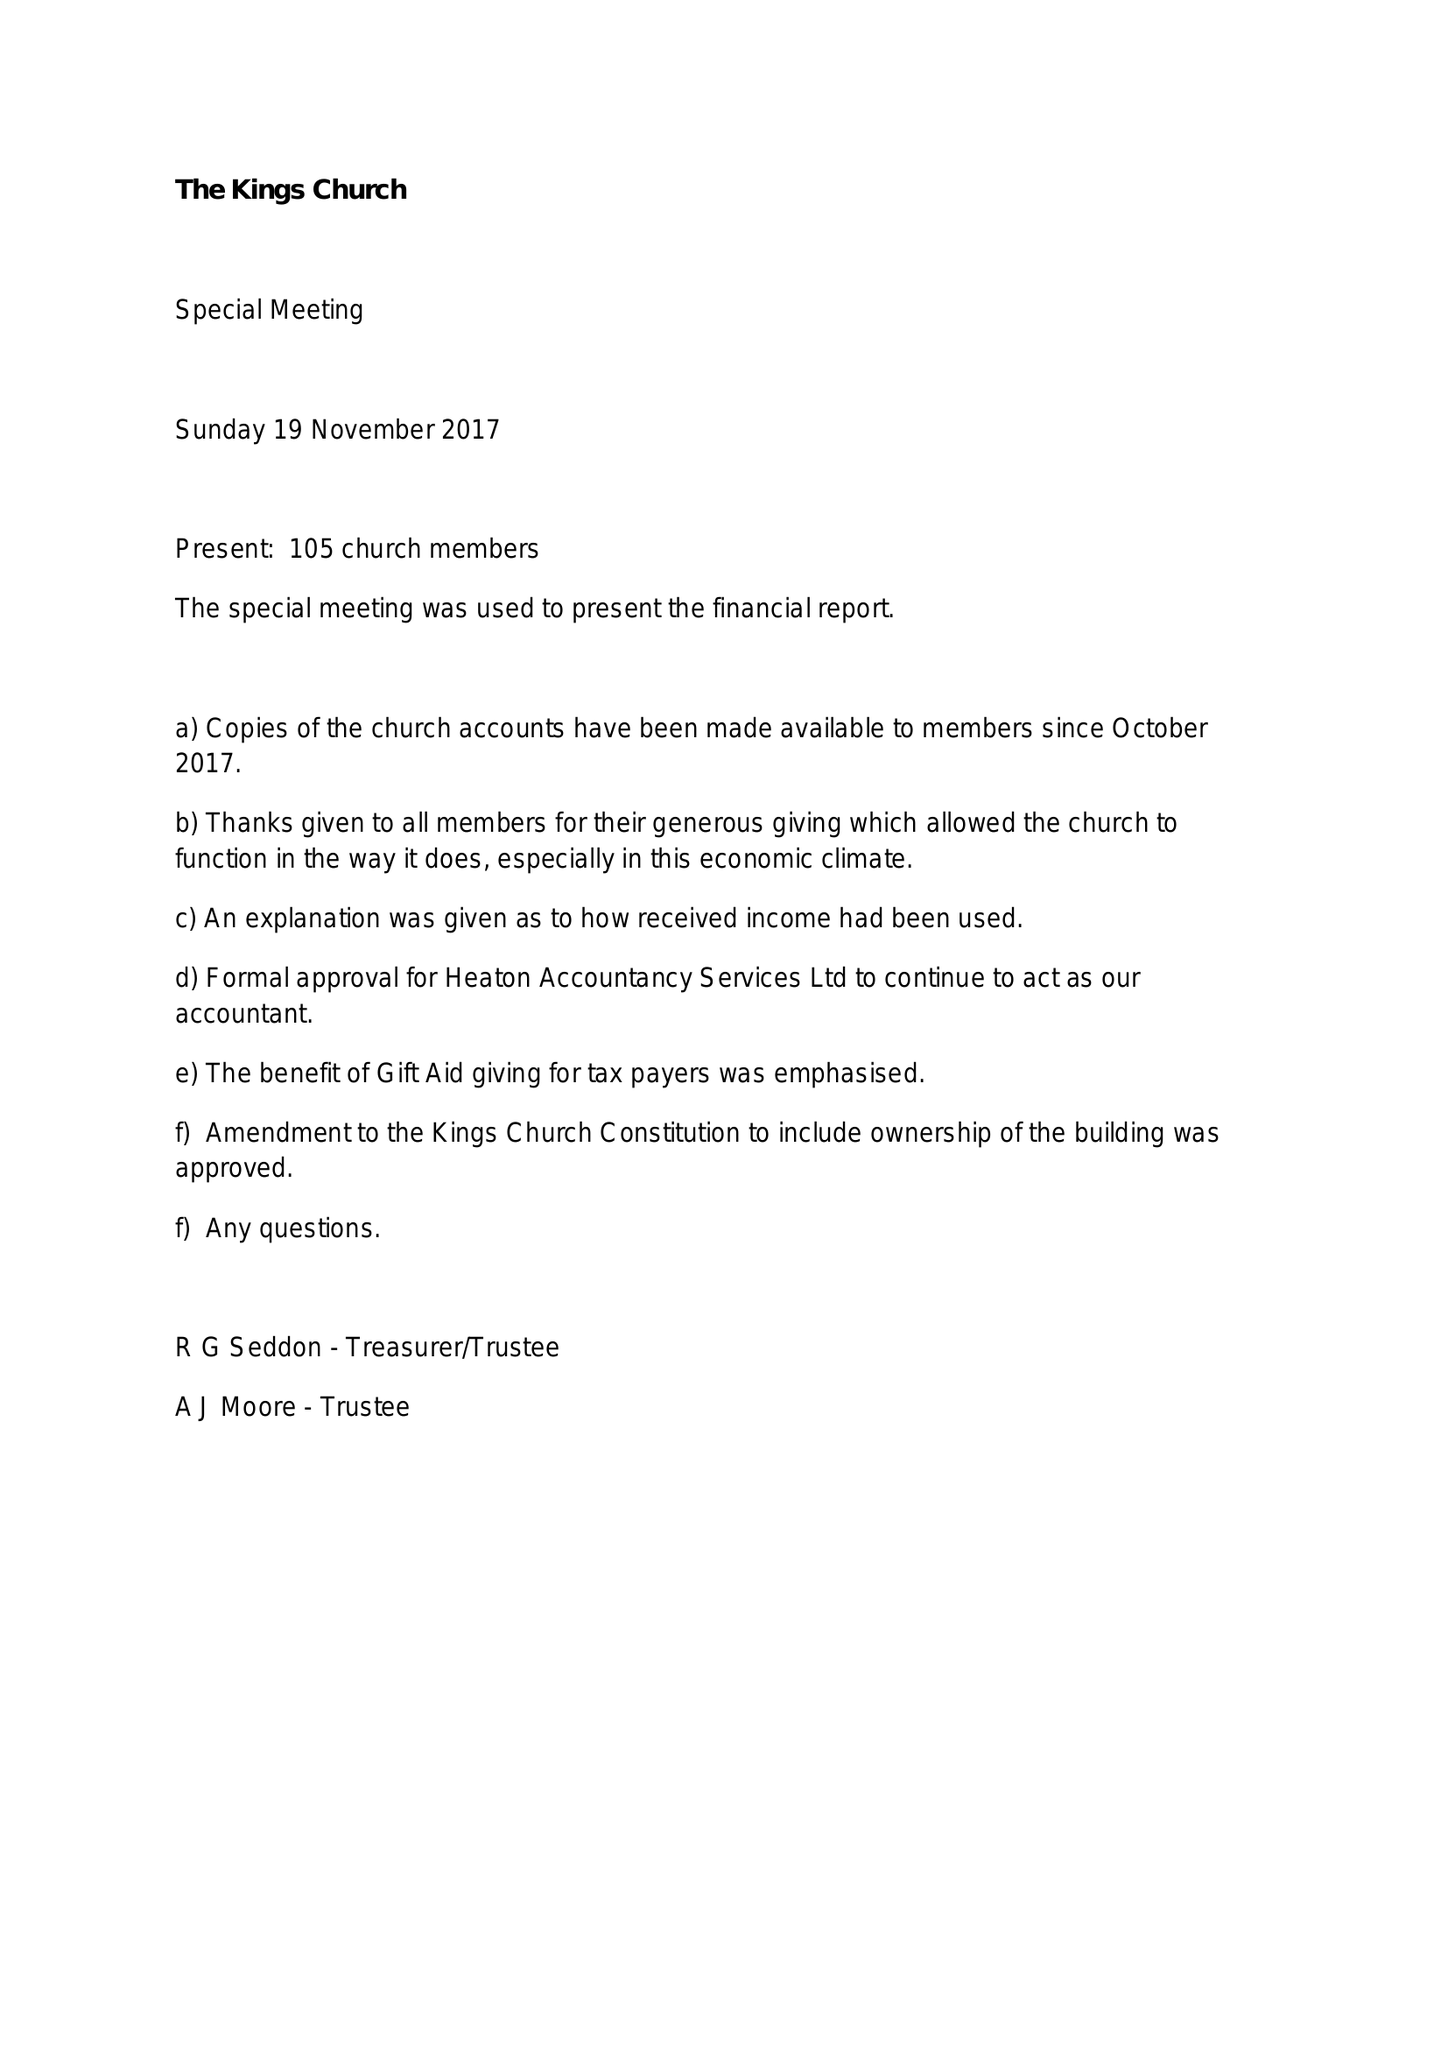What is the value for the spending_annually_in_british_pounds?
Answer the question using a single word or phrase. 61585.00 